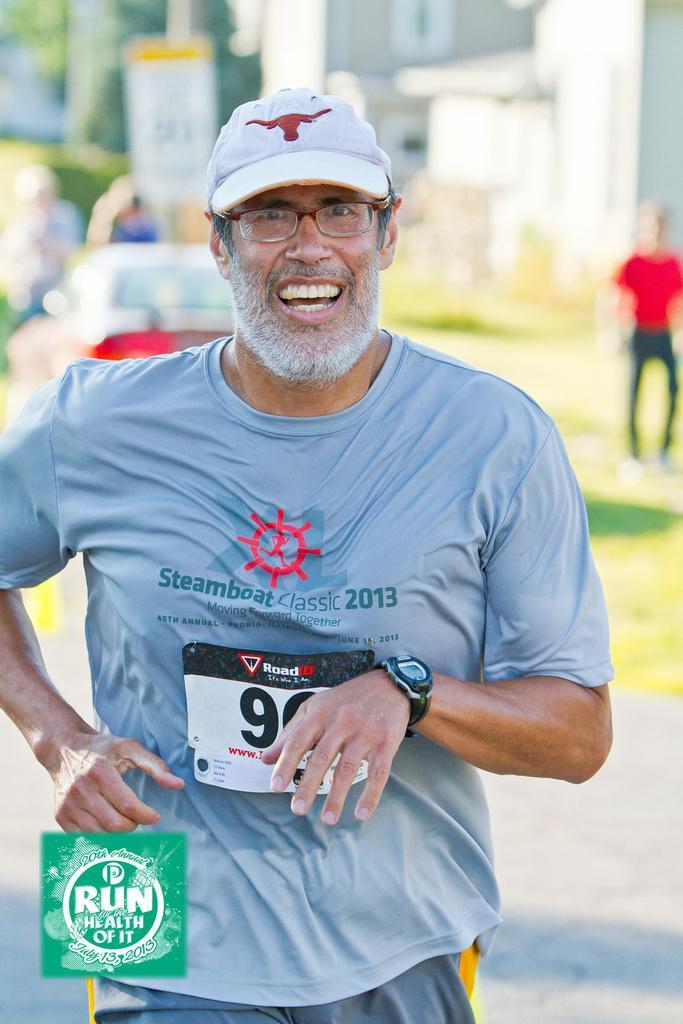Could you give a brief overview of what you see in this image? In this image we can see a person wearing a cap and running, behind him, we can see some persons, trees, buildings, pillars and a board. 